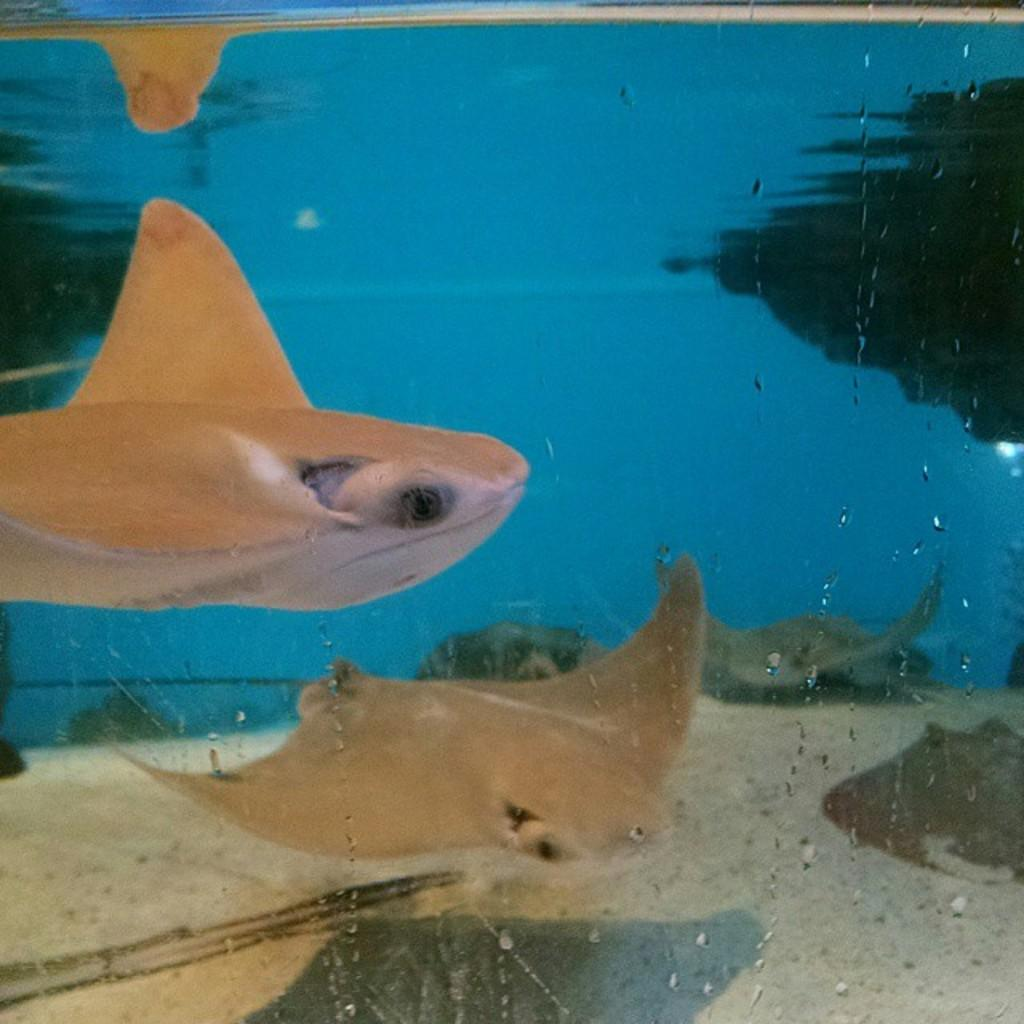What type of animals can be seen in the image? There are fishes in the image. Where are the fishes located? The fishes are present in an aquarium. What type of cake is being served in the image? There is no cake present in the image; it features fishes in an aquarium. What type of writing can be seen on the aquarium in the image? There is no writing visible on the aquarium in the image. 